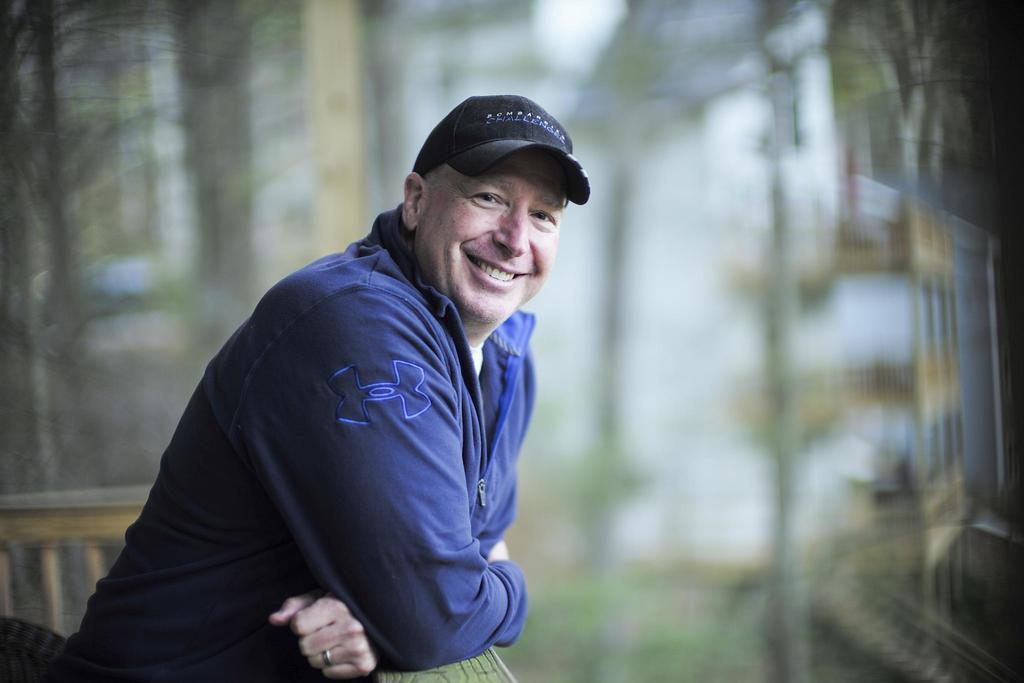What is the main subject of the image? There is a person standing in the image. What can be seen in the background of the image? There is a fence in the image. How many gold pigs are visible in the image? There are no gold pigs present in the image. 